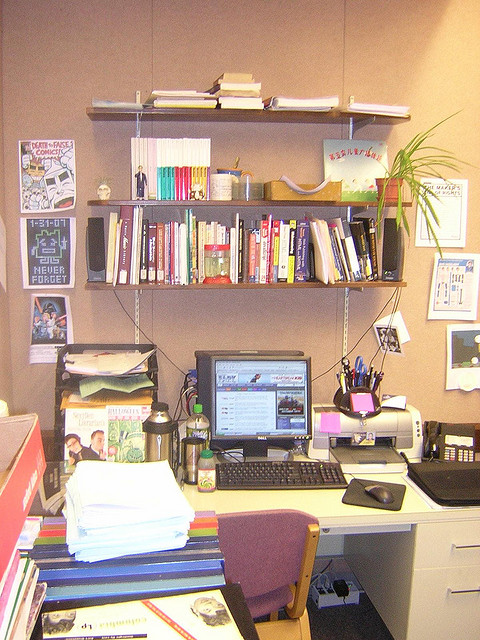Please transcribe the text in this image. NEVER 